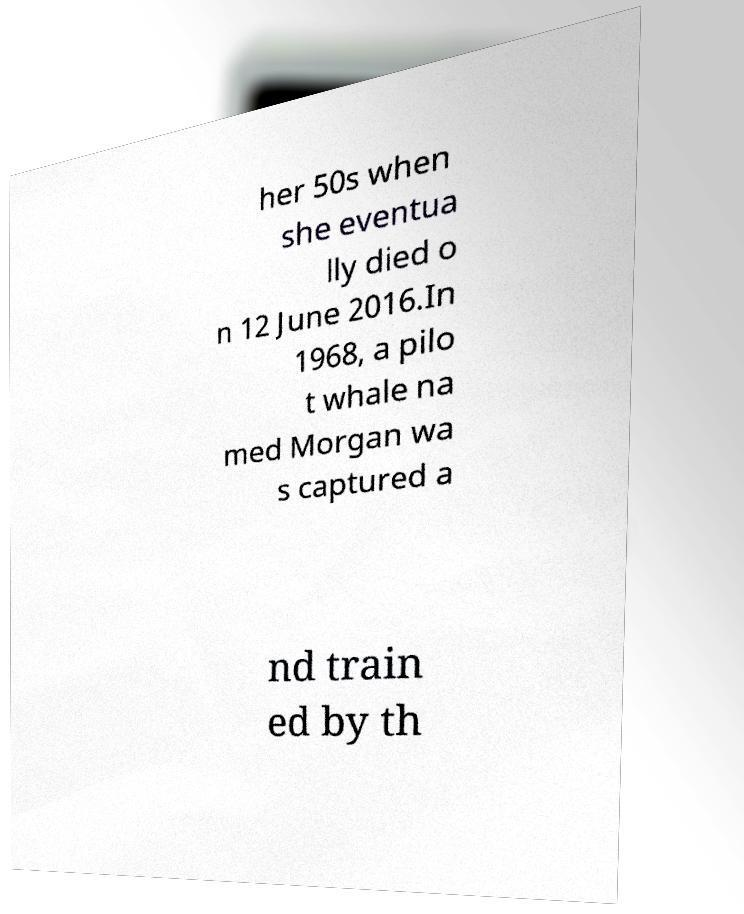For documentation purposes, I need the text within this image transcribed. Could you provide that? her 50s when she eventua lly died o n 12 June 2016.In 1968, a pilo t whale na med Morgan wa s captured a nd train ed by th 